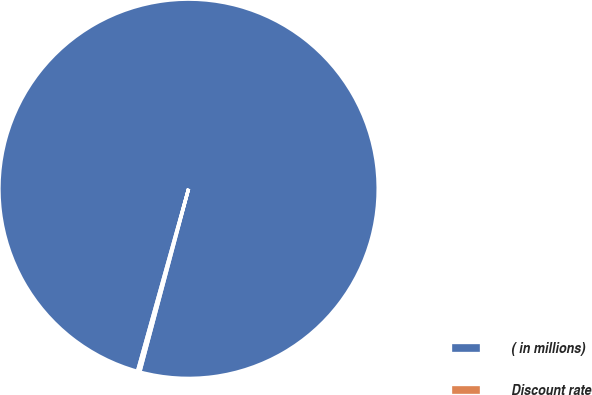Convert chart. <chart><loc_0><loc_0><loc_500><loc_500><pie_chart><fcel>( in millions)<fcel>Discount rate<nl><fcel>99.79%<fcel>0.21%<nl></chart> 